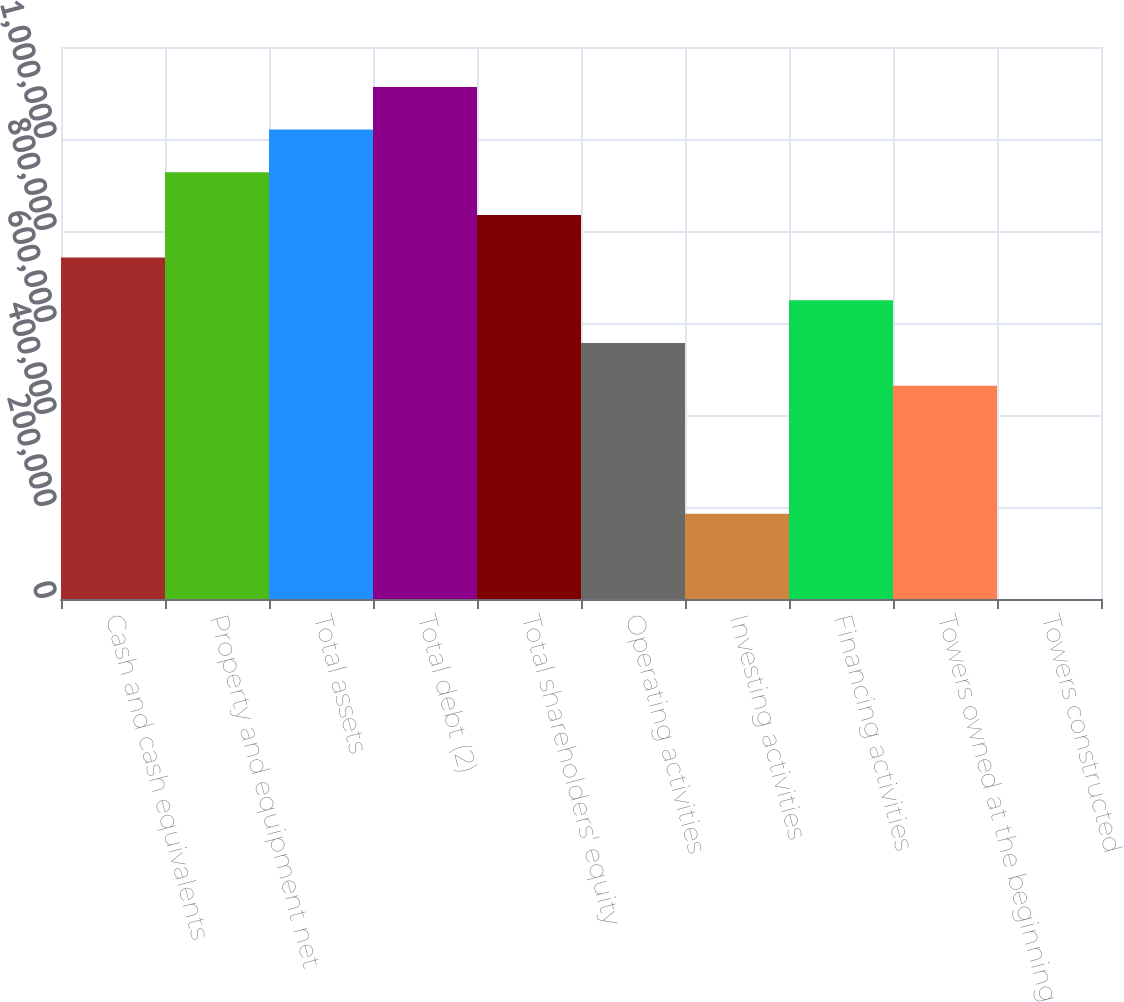Convert chart to OTSL. <chart><loc_0><loc_0><loc_500><loc_500><bar_chart><fcel>Cash and cash equivalents<fcel>Property and equipment net<fcel>Total assets<fcel>Total debt (2)<fcel>Total shareholders' equity<fcel>Operating activities<fcel>Investing activities<fcel>Financing activities<fcel>Towers owned at the beginning<fcel>Towers constructed<nl><fcel>742167<fcel>927706<fcel>1.02048e+06<fcel>1.11325e+06<fcel>834936<fcel>556628<fcel>185549<fcel>649397<fcel>463858<fcel>10<nl></chart> 